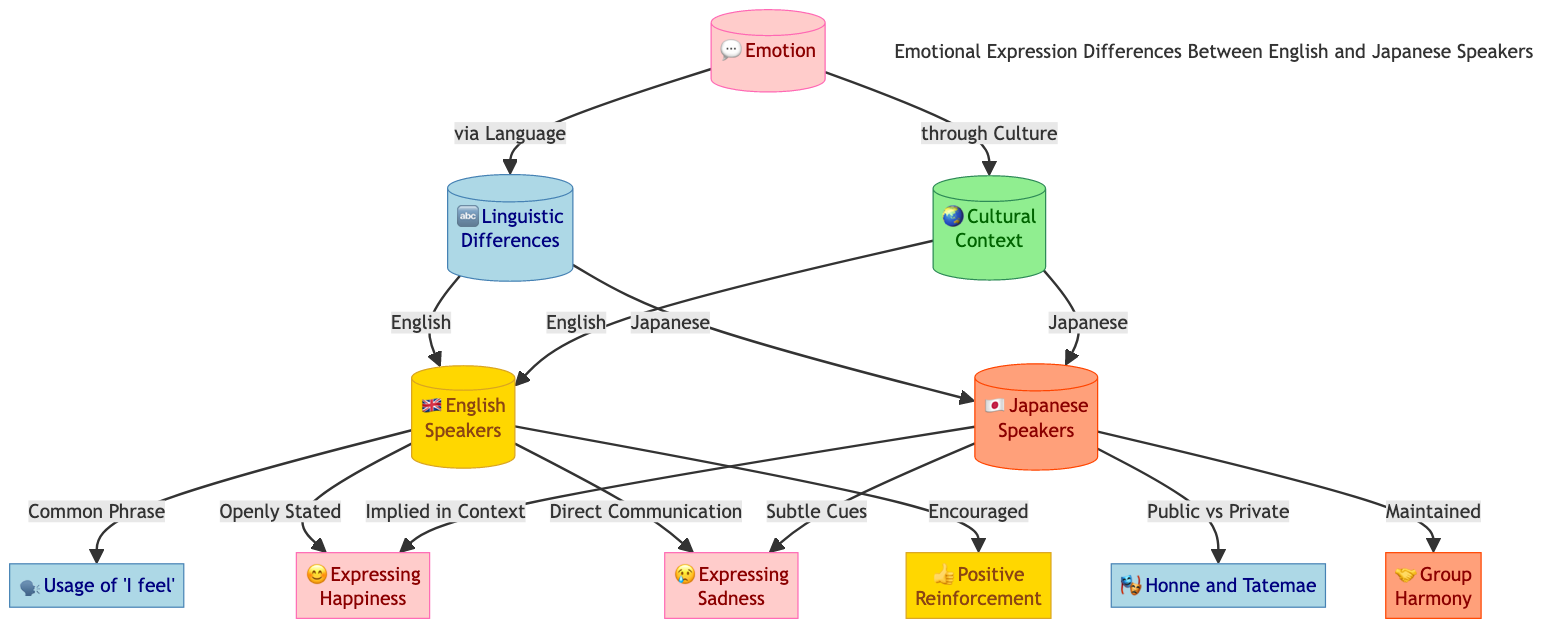What are the two main types of nodes in the diagram? The diagram features nodes representing emotions and cultural/linguistic contexts. Specifically, emotions are shown in the "Emotion" category, while the cultural and linguistic differences are shown under "Cultural Context" and "Linguistic Differences."
Answer: Emotion, Cultural Context, Linguistic Differences How many specific emotions are represented in the diagram? There are two specific emotions represented in the diagram: Happiness and Sadness, shown in the nodes. Each emotion has distinct expressions based on the cultural context of English and Japanese speakers.
Answer: 2 What is the primary emotional expression method for English speakers regarding happiness? The diagram shows that English speakers express happiness through open statements, categorized under "Expressing Happiness." In this case, it corresponds to direct communication.
Answer: Openly Stated How do Japanese speakers typically imply happiness? The diagram illustrates that Japanese speakers express happiness through context rather than directly stating it, which is indicated under "Expressing Happiness" in the Japanese context.
Answer: Implied in Context What is one significant difference in expressing sadness between English and Japanese speakers? The diagram highlights that English speakers express sadness directly, which is termed "Direct Communication," while Japanese speakers utilize "Subtle Cues" to express their sadness.
Answer: Direct Communication, Subtle Cues How does cultural context differentiate the emotional expression of group harmony between the two languages? According to the diagram, this is illustrated under "Cultural Context," where it is noted that English speakers tend to use positive reinforcement, while Japanese speakers place emphasis on group harmony, demonstrating differing cultural values in emotional expression.
Answer: Positive Reinforcement, Group Harmony What color represents linguistic differences in the diagram? The color representing linguistic differences in the diagram is light blue, which is visually coded to label this specific aspect of emotional expression.
Answer: Light Blue How are the terms 'Honne and Tatemae' related to Japanese emotional expression? The diagram connects 'Honne and Tatemae' to the Japanese speakers' cultural context under linguistic differences, indicating the distinction between public versus private emotional expression.
Answer: Public vs Private 